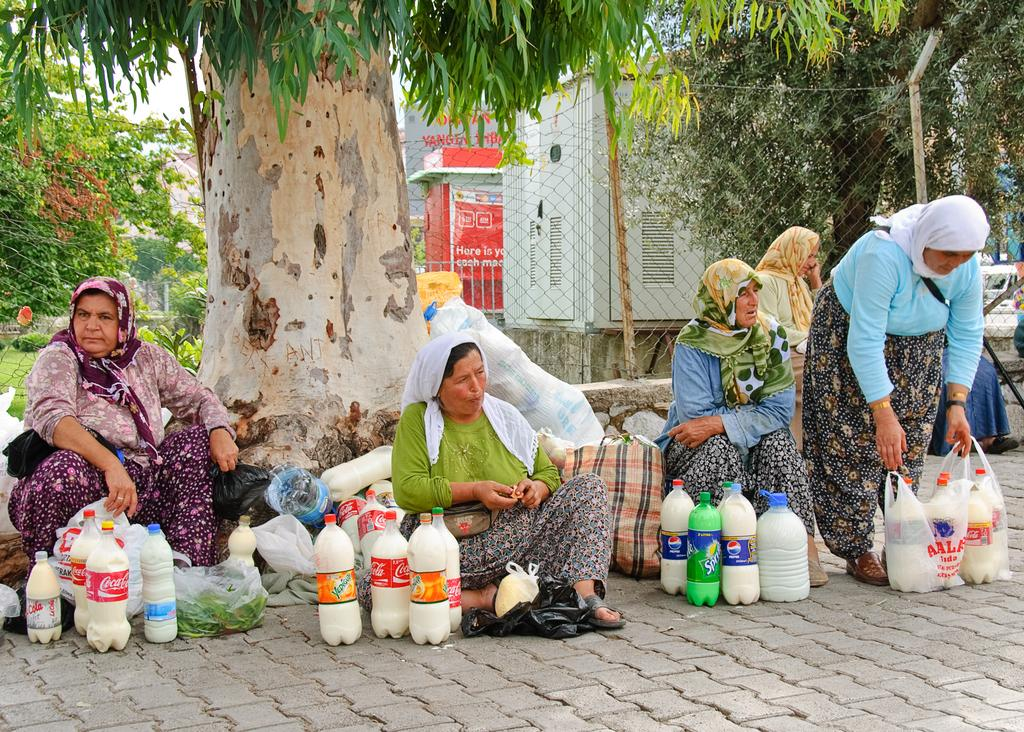Who or what can be seen in the image? There are people in the image. What items are visible in the image? There are bottles, covers, and bags in the image. Can you describe any other objects present in the image? Yes, there are other objects in the image. What can be seen in the background of the image? There are trees, sheds, and a fence in the background of the image. What type of quiver is being used by the people in the image? There is no quiver present in the image. How does the pain affect the people in the image? There is no mention of pain or any indication that the people in the image are experiencing pain. 